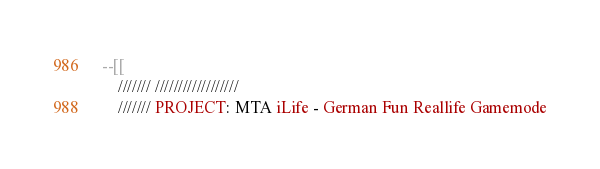Convert code to text. <code><loc_0><loc_0><loc_500><loc_500><_Lua_>--[[
	/////// //////////////////
	/////// PROJECT: MTA iLife - German Fun Reallife Gamemode</code> 